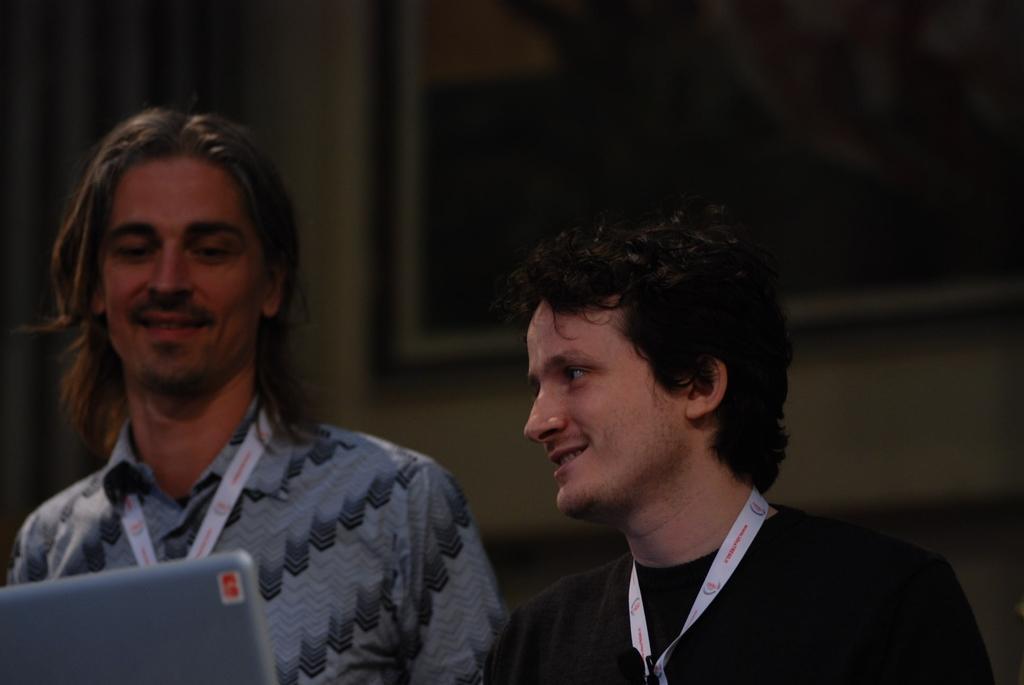Please provide a concise description of this image. In this picture there are two persons and there is a laptop in front of them in the left corner and there is a photo frame attached to the wall in the background. 